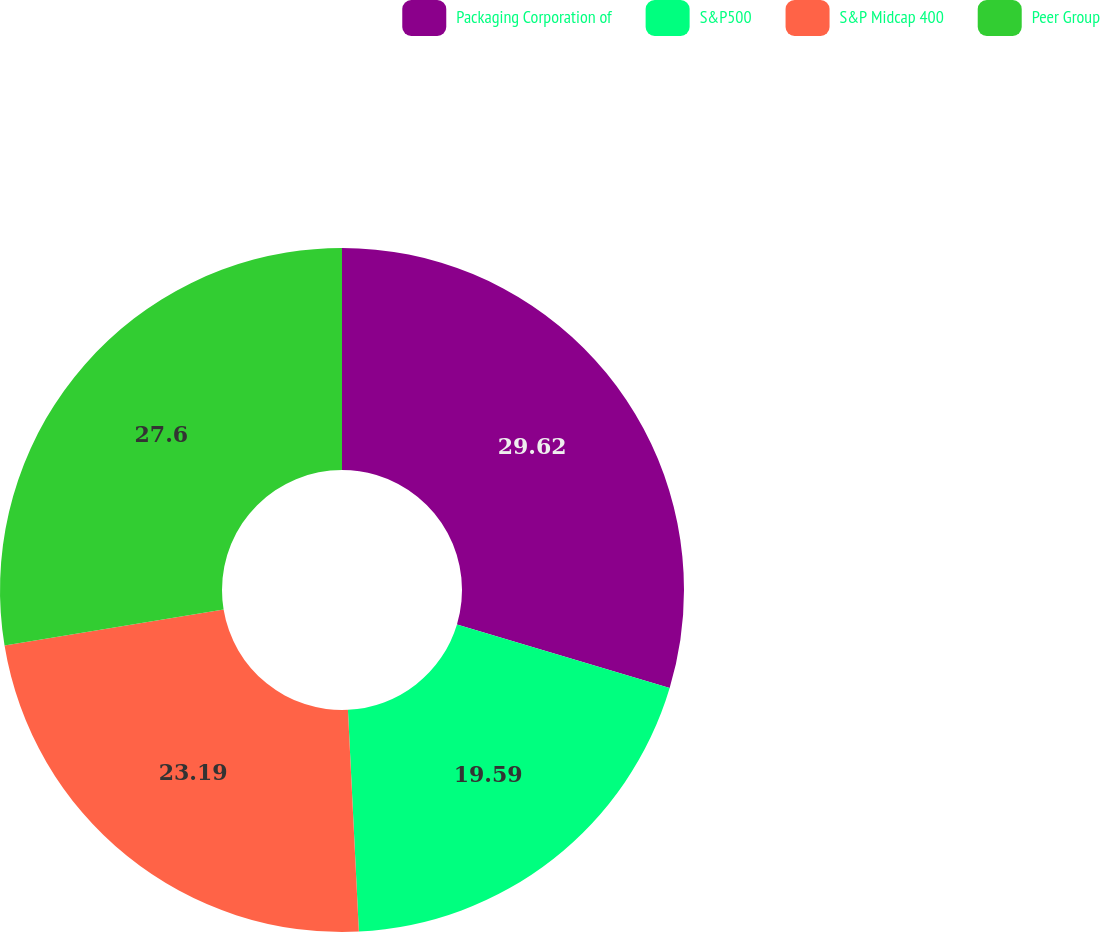Convert chart to OTSL. <chart><loc_0><loc_0><loc_500><loc_500><pie_chart><fcel>Packaging Corporation of<fcel>S&P500<fcel>S&P Midcap 400<fcel>Peer Group<nl><fcel>29.63%<fcel>19.59%<fcel>23.19%<fcel>27.6%<nl></chart> 